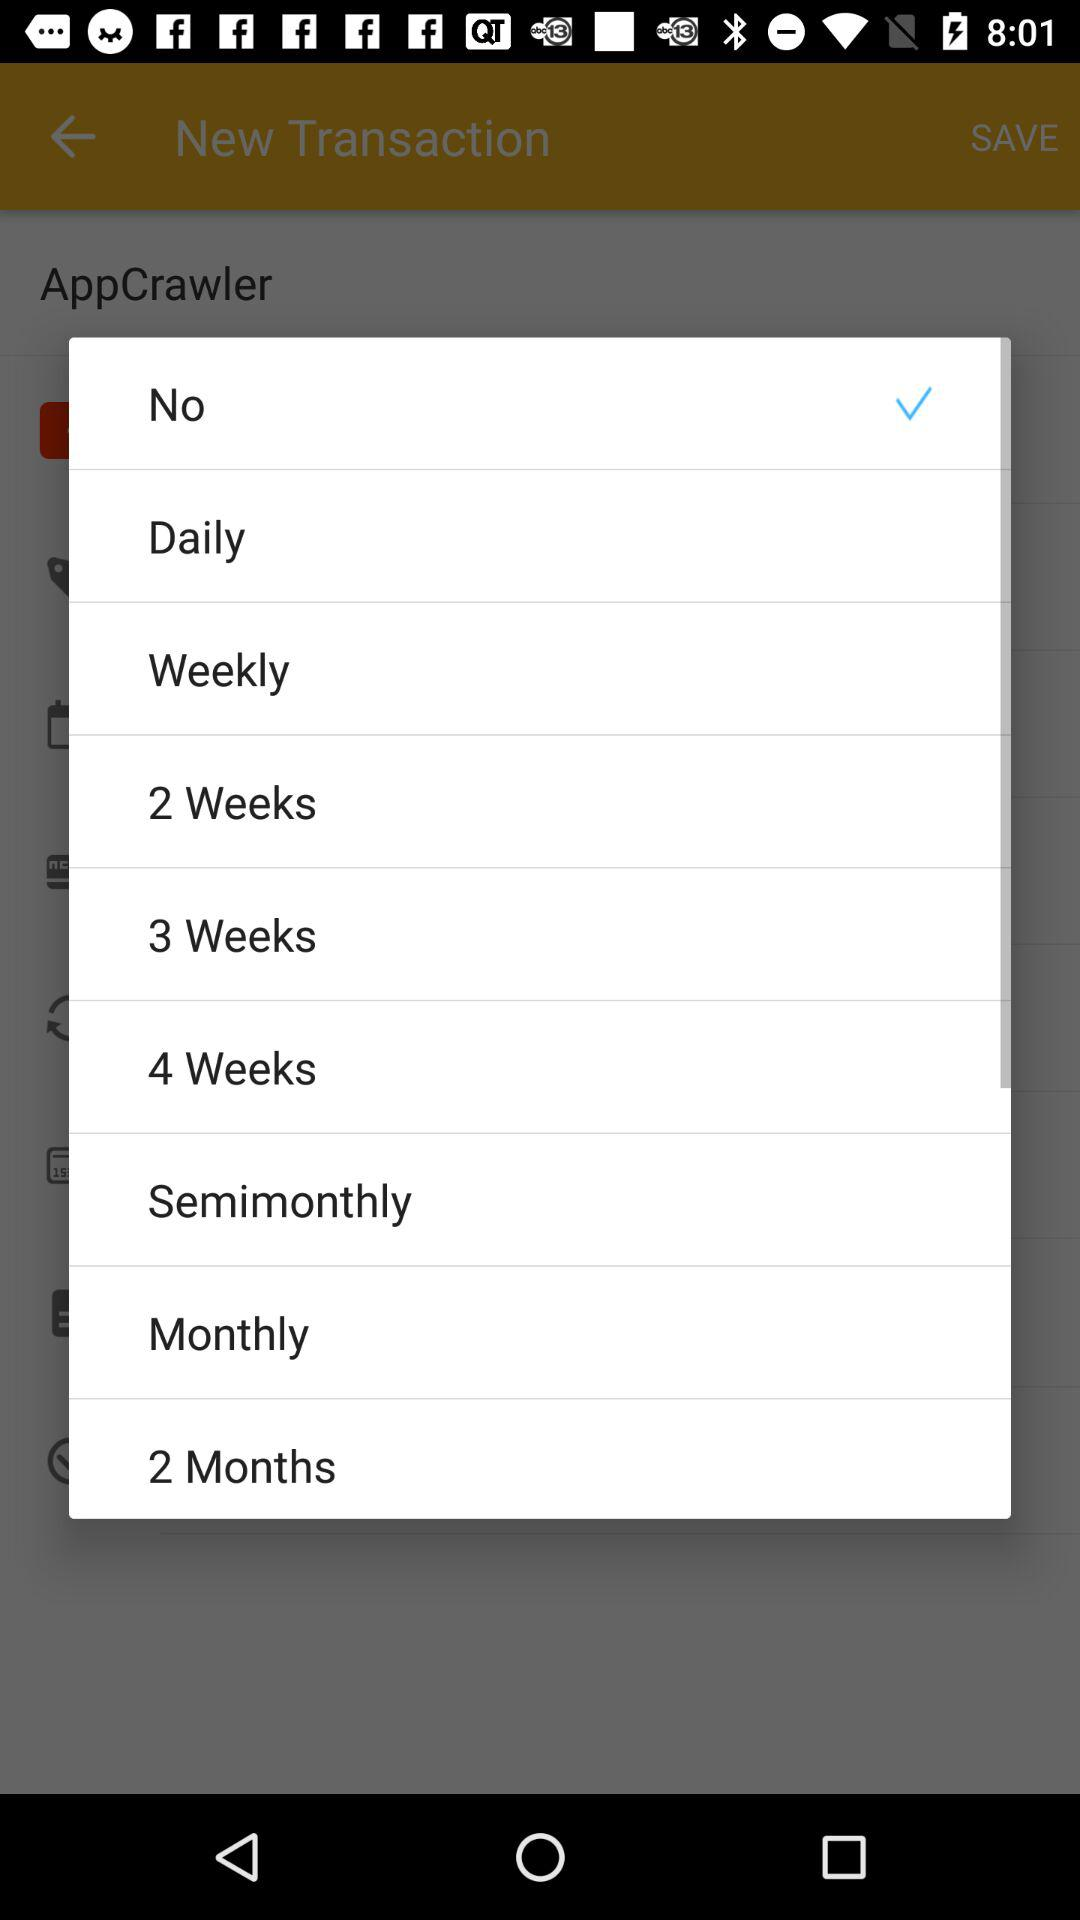Which is the selected option? The selected option is "No". 